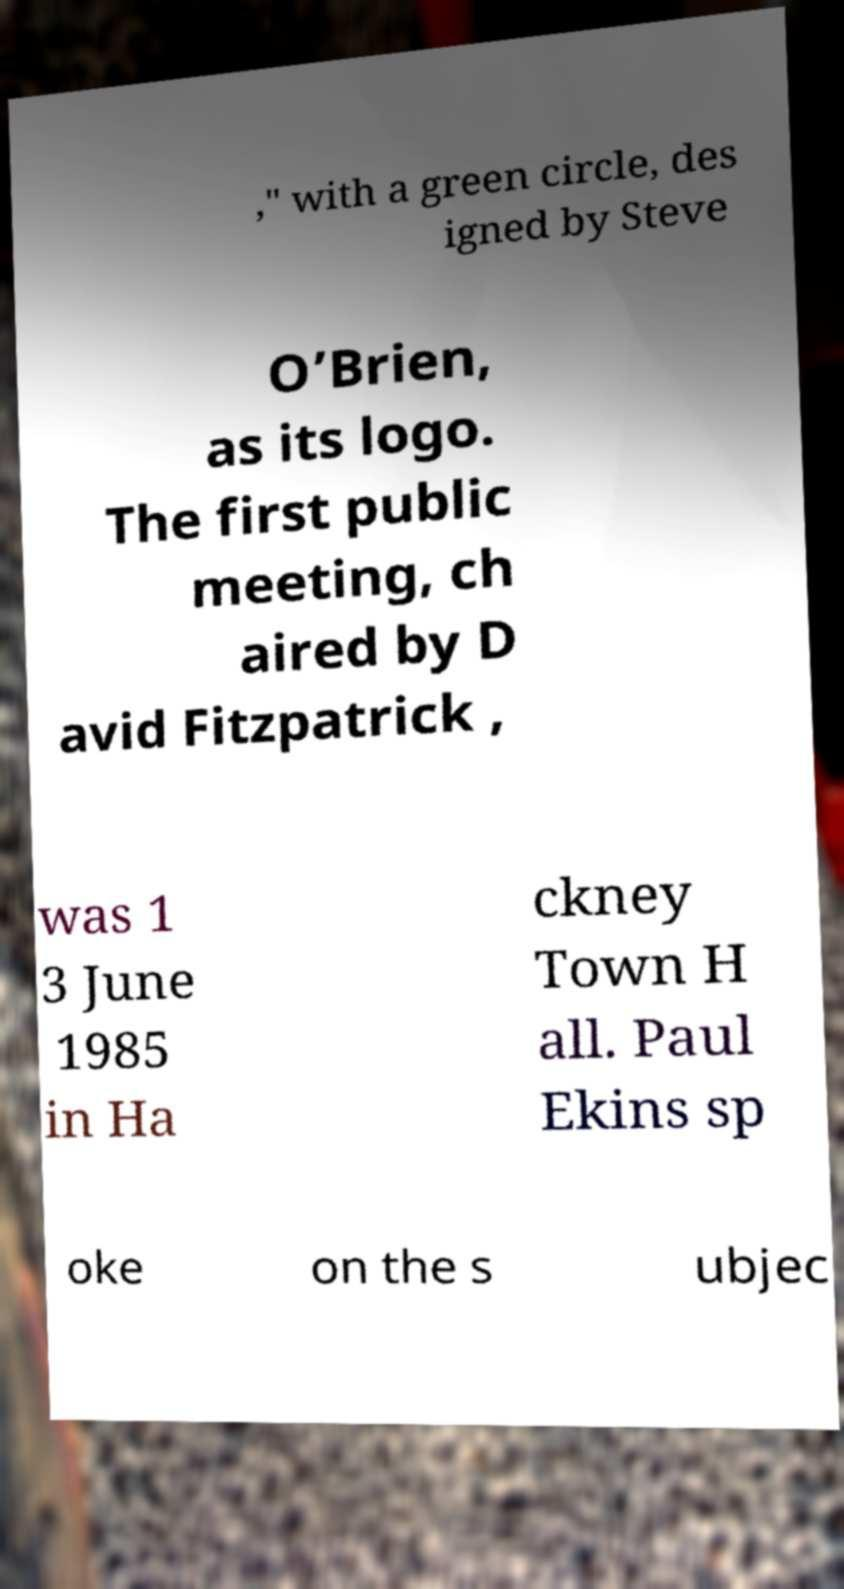For documentation purposes, I need the text within this image transcribed. Could you provide that? ," with a green circle, des igned by Steve O’Brien, as its logo. The first public meeting, ch aired by D avid Fitzpatrick , was 1 3 June 1985 in Ha ckney Town H all. Paul Ekins sp oke on the s ubjec 